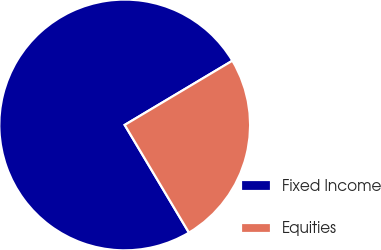<chart> <loc_0><loc_0><loc_500><loc_500><pie_chart><fcel>Fixed Income<fcel>Equities<nl><fcel>75.0%<fcel>25.0%<nl></chart> 